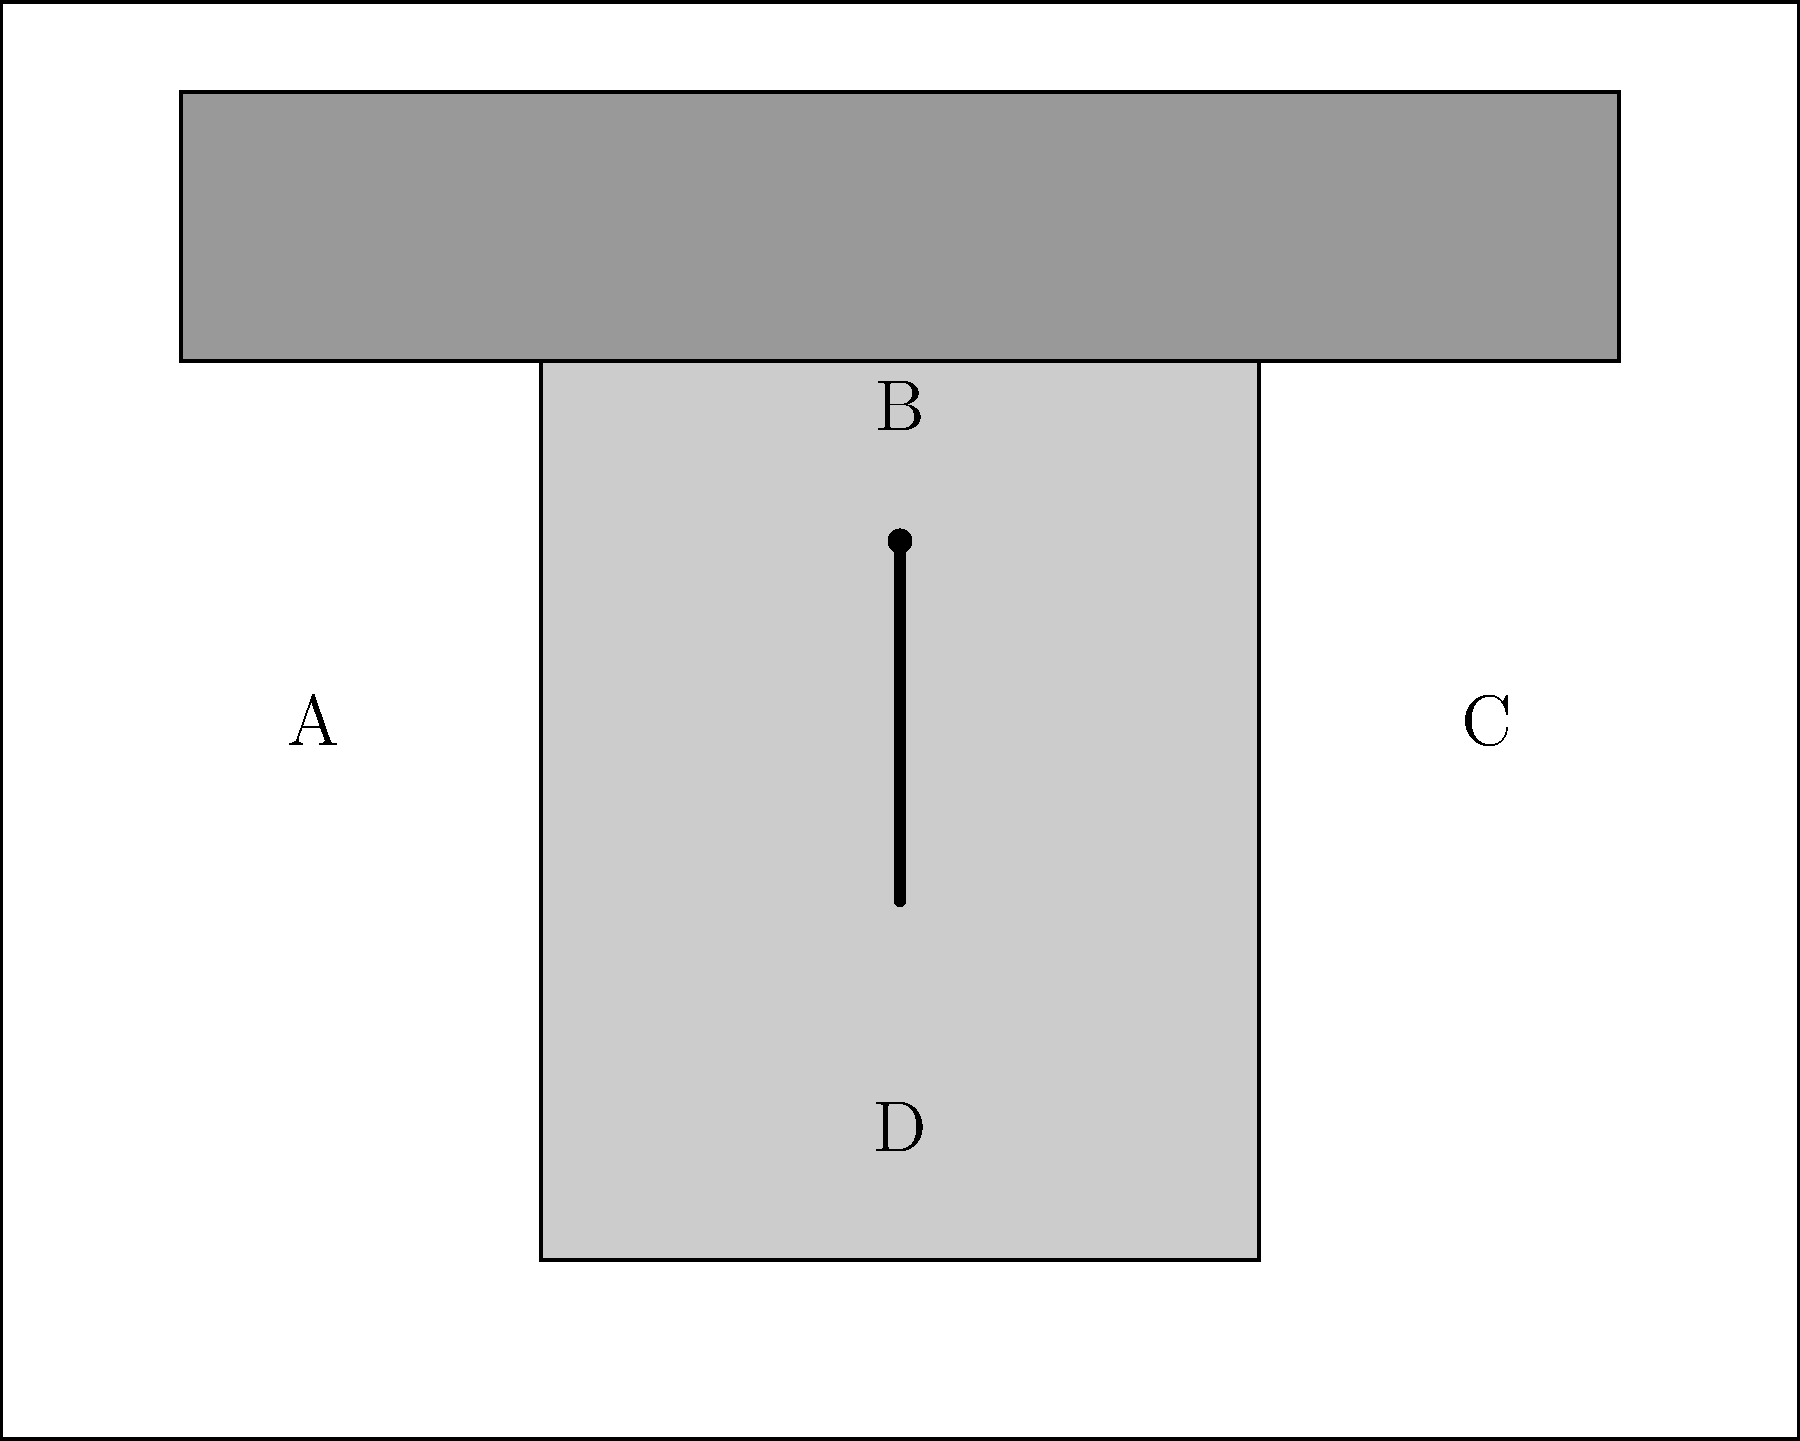In the schematic of a World War II fighter aircraft cockpit, which labeled component represents the control stick, and how did its design impact pilot performance during high-G maneuvers? To answer this question, we need to analyze the schematic and understand the historical context of World War II aircraft design:

1. Identify the components:
   A: Side panel
   B: Control stick
   C: Instrument panel
   D: Seat base

2. The control stick is labeled as "B" in the schematic. It's the vertical line with a dot at the top, representing the grip.

3. Historical context of control stick design:
   - Early WWII fighters used longer control sticks positioned between the pilot's legs.
   - This design allowed for precise control but had drawbacks during high-G maneuvers.

4. Impact on pilot performance during high-G maneuvers:
   - Long sticks made it difficult for pilots to brace themselves during tight turns.
   - Pilots could inadvertently apply pressure to the stick during G-forces, leading to unintended aircraft movements.

5. Design improvements:
   - Later WWII fighters introduced shorter, side-mounted control sticks.
   - This allowed pilots to rest their arm on their leg, providing better support during high-G maneuvers.
   - The new design reduced pilot fatigue and improved control accuracy in combat situations.

6. Overall impact:
   - The evolution of control stick design during WWII significantly enhanced pilot performance and aircraft handling in dogfights.
   - It contributed to the improved combat effectiveness of later war fighter aircraft.
Answer: B; long, center-mounted sticks hindered control in high-G maneuvers, leading to shorter, side-mounted designs for improved performance. 